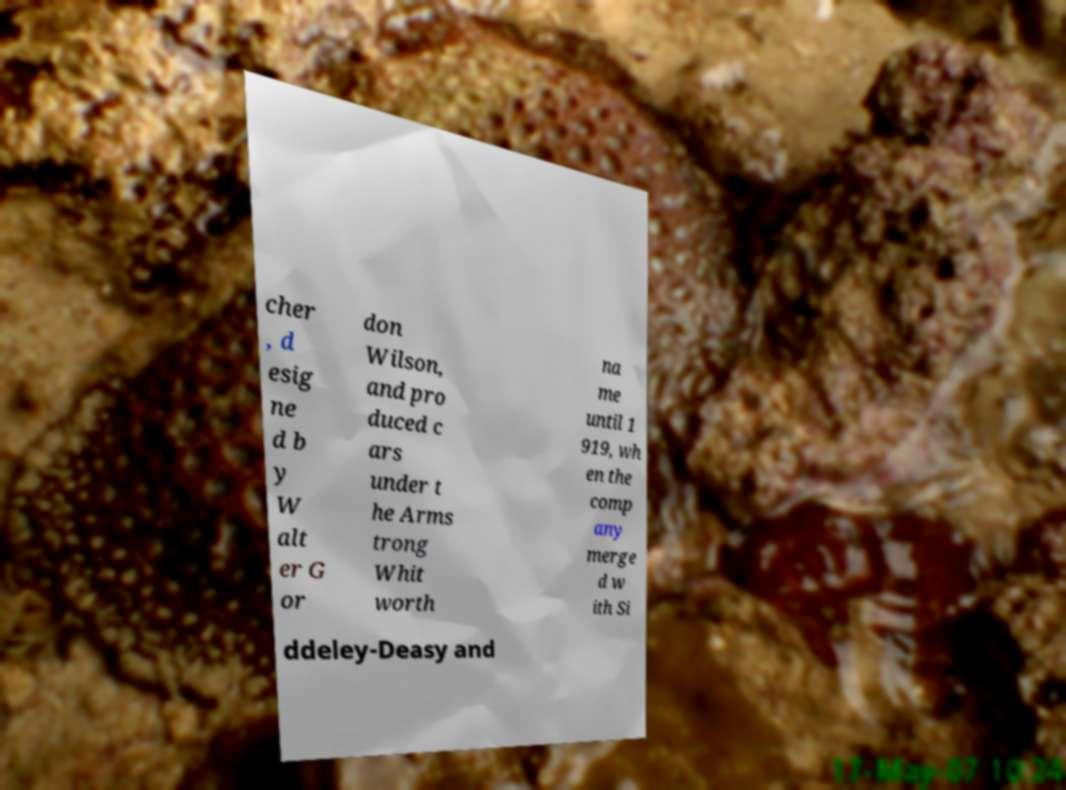I need the written content from this picture converted into text. Can you do that? cher , d esig ne d b y W alt er G or don Wilson, and pro duced c ars under t he Arms trong Whit worth na me until 1 919, wh en the comp any merge d w ith Si ddeley-Deasy and 